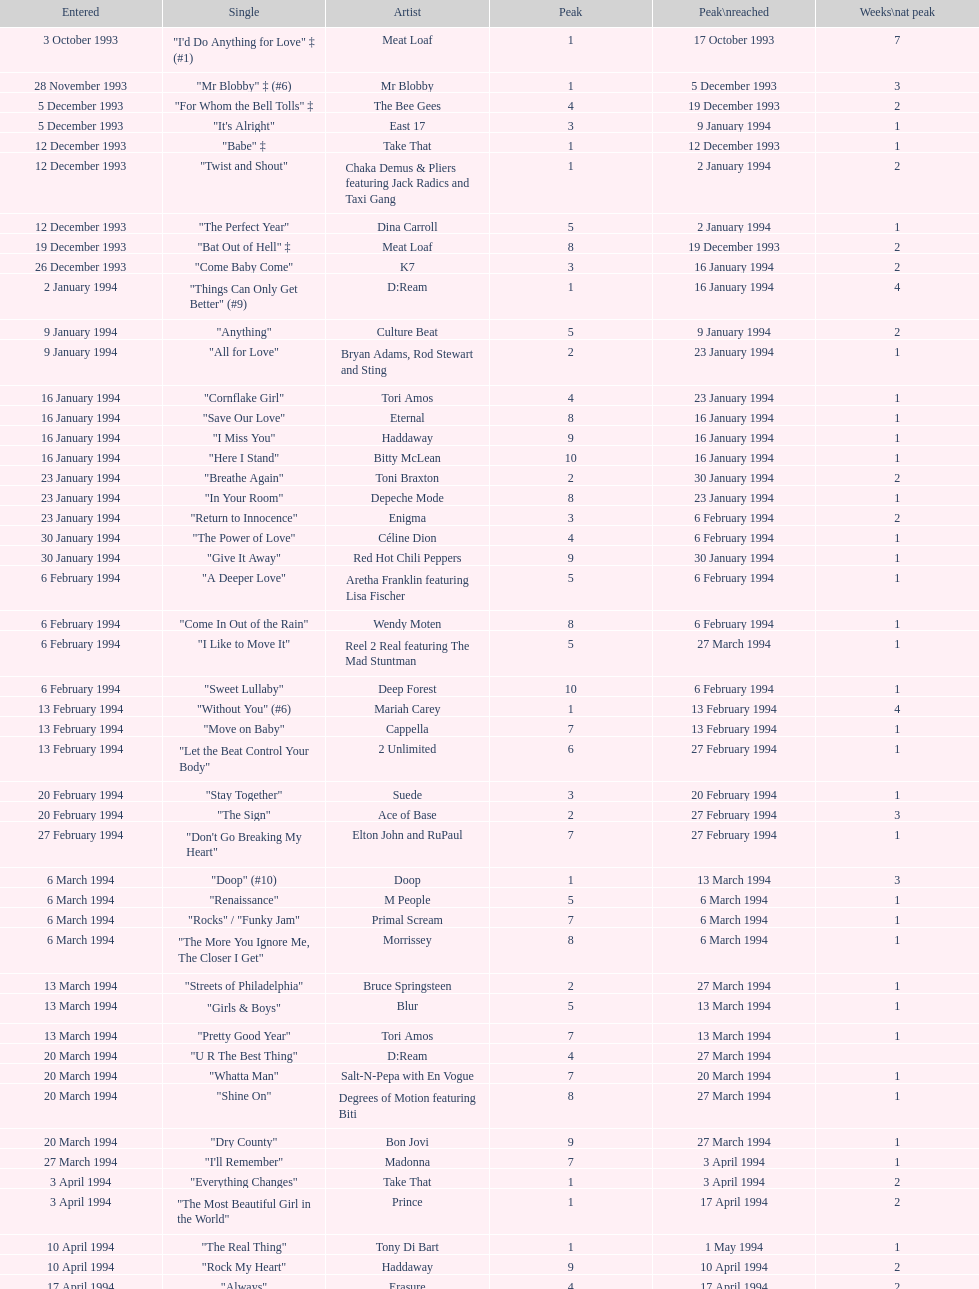Which artist came on the list after oasis? Tinman. 